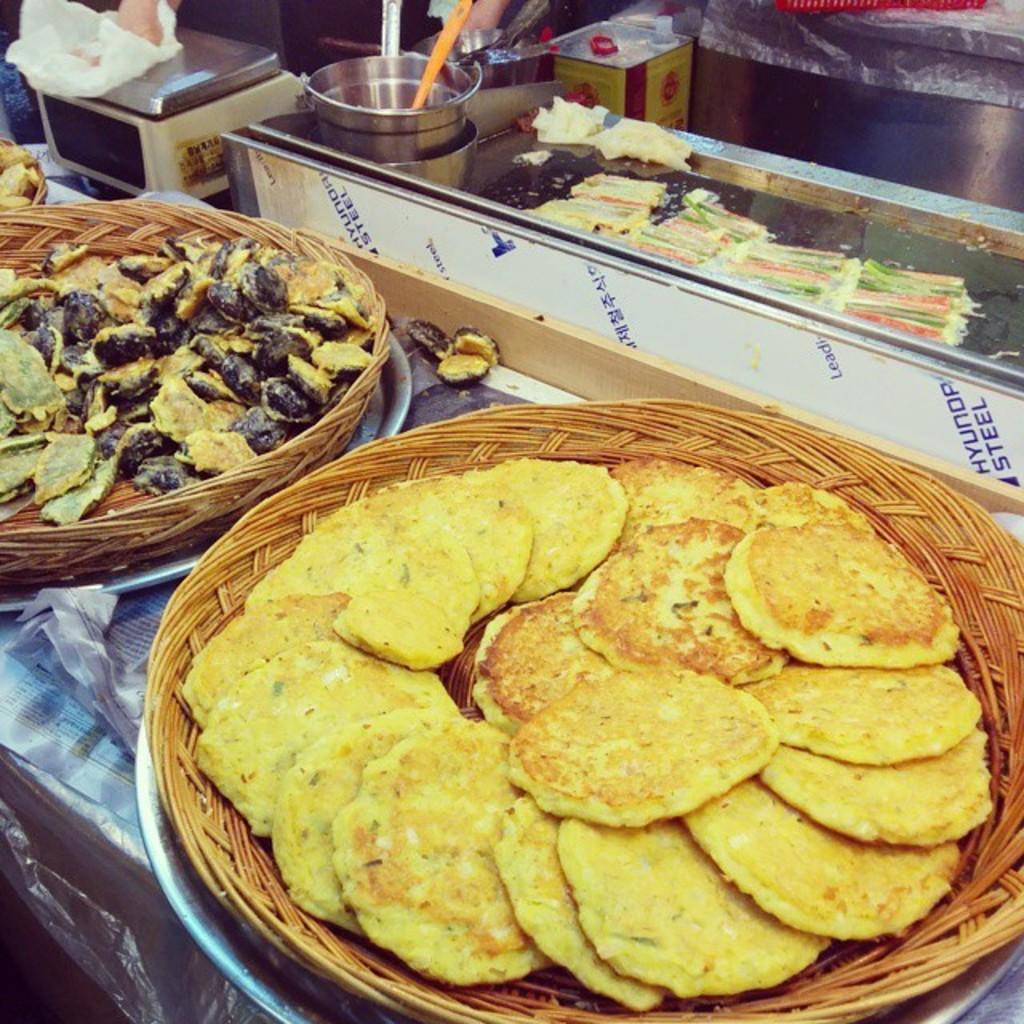Can you describe this image briefly? In this image, I can see the wooden baskets with the food items on it. This looks like a table with the utensils and few other objects on it. At the top of the image, that looks like an oil can. I think this is an electronic weighing machine. 